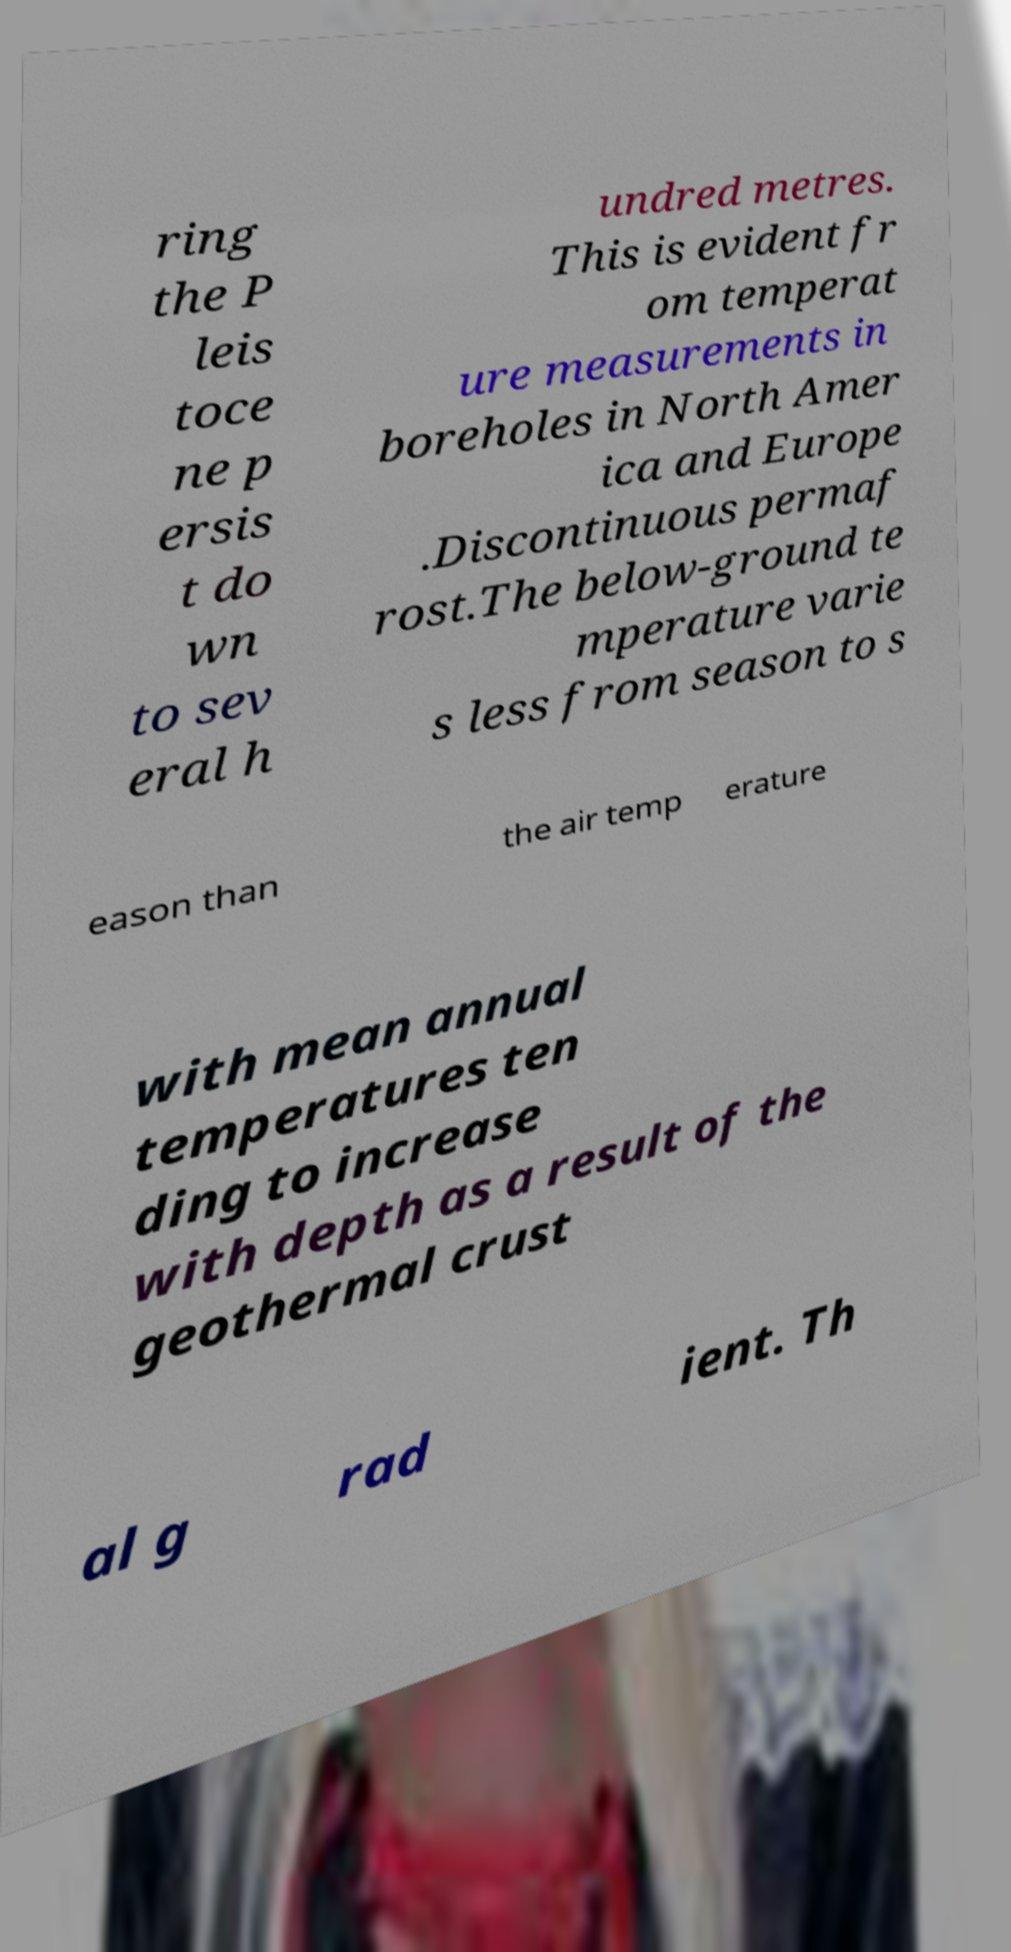Can you read and provide the text displayed in the image?This photo seems to have some interesting text. Can you extract and type it out for me? ring the P leis toce ne p ersis t do wn to sev eral h undred metres. This is evident fr om temperat ure measurements in boreholes in North Amer ica and Europe .Discontinuous permaf rost.The below-ground te mperature varie s less from season to s eason than the air temp erature with mean annual temperatures ten ding to increase with depth as a result of the geothermal crust al g rad ient. Th 